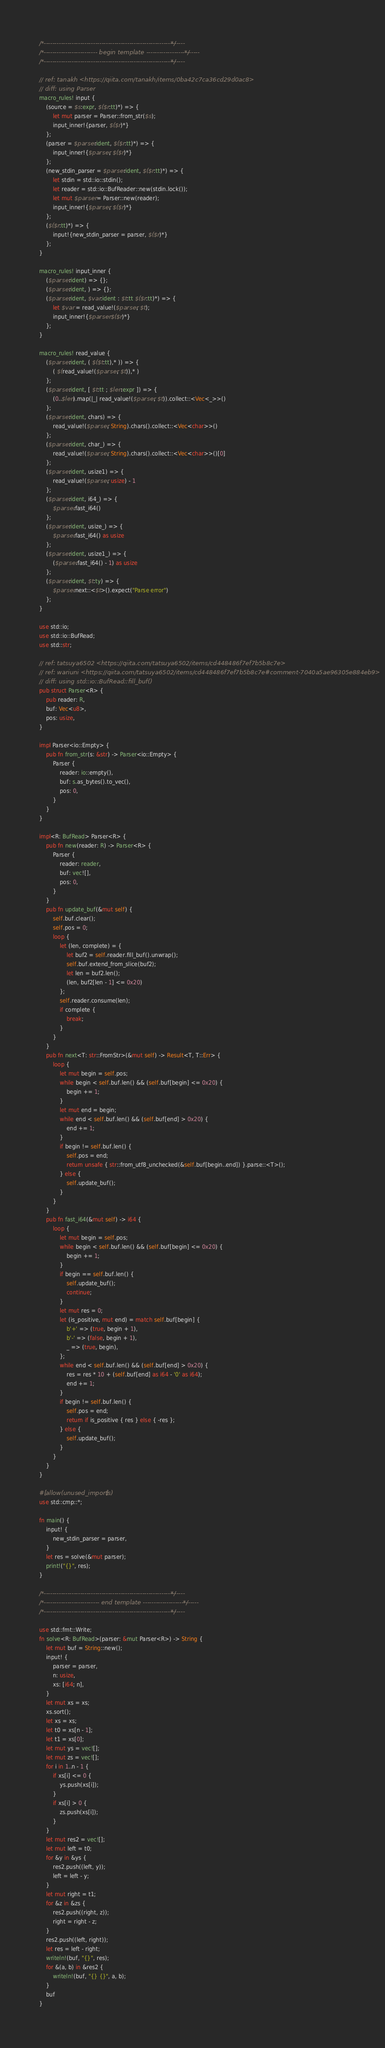Convert code to text. <code><loc_0><loc_0><loc_500><loc_500><_Rust_>/*------------------------------------------------------------------*/
/*------------------------- begin template -------------------------*/
/*------------------------------------------------------------------*/

// ref: tanakh <https://qiita.com/tanakh/items/0ba42c7ca36cd29d0ac8>
// diff: using Parser
macro_rules! input {
    (source = $s:expr, $($r:tt)*) => {
        let mut parser = Parser::from_str($s);
        input_inner!{parser, $($r)*}
    };
    (parser = $parser:ident, $($r:tt)*) => {
        input_inner!{$parser, $($r)*}
    };
    (new_stdin_parser = $parser:ident, $($r:tt)*) => {
        let stdin = std::io::stdin();
        let reader = std::io::BufReader::new(stdin.lock());
        let mut $parser = Parser::new(reader);
        input_inner!{$parser, $($r)*}
    };
    ($($r:tt)*) => {
        input!{new_stdin_parser = parser, $($r)*}
    };
}

macro_rules! input_inner {
    ($parser:ident) => {};
    ($parser:ident, ) => {};
    ($parser:ident, $var:ident : $t:tt $($r:tt)*) => {
        let $var = read_value!($parser, $t);
        input_inner!{$parser $($r)*}
    };
}

macro_rules! read_value {
    ($parser:ident, ( $($t:tt),* )) => {
        ( $(read_value!($parser, $t)),* )
    };
    ($parser:ident, [ $t:tt ; $len:expr ]) => {
        (0..$len).map(|_| read_value!($parser, $t)).collect::<Vec<_>>()
    };
    ($parser:ident, chars) => {
        read_value!($parser, String).chars().collect::<Vec<char>>()
    };
    ($parser:ident, char_) => {
        read_value!($parser, String).chars().collect::<Vec<char>>()[0]
    };
    ($parser:ident, usize1) => {
        read_value!($parser, usize) - 1
    };
    ($parser:ident, i64_) => {
        $parser.fast_i64()
    };
    ($parser:ident, usize_) => {
        $parser.fast_i64() as usize
    };
    ($parser:ident, usize1_) => {
        ($parser.fast_i64() - 1) as usize
    };
    ($parser:ident, $t:ty) => {
        $parser.next::<$t>().expect("Parse error")
    };
}

use std::io;
use std::io::BufRead;
use std::str;

// ref: tatsuya6502 <https://qiita.com/tatsuya6502/items/cd448486f7ef7b5b8c7e>
// ref: wariuni <https://qiita.com/tatsuya6502/items/cd448486f7ef7b5b8c7e#comment-7040a5ae96305e884eb9>
// diff: using std::io::BufRead::fill_buf()
pub struct Parser<R> {
    pub reader: R,
    buf: Vec<u8>,
    pos: usize,
}

impl Parser<io::Empty> {
    pub fn from_str(s: &str) -> Parser<io::Empty> {
        Parser {
            reader: io::empty(),
            buf: s.as_bytes().to_vec(),
            pos: 0,
        }
    }
}

impl<R: BufRead> Parser<R> {
    pub fn new(reader: R) -> Parser<R> {
        Parser {
            reader: reader,
            buf: vec![],
            pos: 0,
        }
    }
    pub fn update_buf(&mut self) {
        self.buf.clear();
        self.pos = 0;
        loop {
            let (len, complete) = {
                let buf2 = self.reader.fill_buf().unwrap();
                self.buf.extend_from_slice(buf2);
                let len = buf2.len();
                (len, buf2[len - 1] <= 0x20)
            };
            self.reader.consume(len);
            if complete {
                break;
            }
        }
    }
    pub fn next<T: str::FromStr>(&mut self) -> Result<T, T::Err> {
        loop {
            let mut begin = self.pos;
            while begin < self.buf.len() && (self.buf[begin] <= 0x20) {
                begin += 1;
            }
            let mut end = begin;
            while end < self.buf.len() && (self.buf[end] > 0x20) {
                end += 1;
            }
            if begin != self.buf.len() {
                self.pos = end;
                return unsafe { str::from_utf8_unchecked(&self.buf[begin..end]) }.parse::<T>();
            } else {
                self.update_buf();
            }
        }
    }
    pub fn fast_i64(&mut self) -> i64 {
        loop {
            let mut begin = self.pos;
            while begin < self.buf.len() && (self.buf[begin] <= 0x20) {
                begin += 1;
            }
            if begin == self.buf.len() {
                self.update_buf();
                continue;
            }
            let mut res = 0;
            let (is_positive, mut end) = match self.buf[begin] {
                b'+' => (true, begin + 1),
                b'-' => (false, begin + 1),
                _ => (true, begin),
            };
            while end < self.buf.len() && (self.buf[end] > 0x20) {
                res = res * 10 + (self.buf[end] as i64 - '0' as i64);
                end += 1;
            }
            if begin != self.buf.len() {
                self.pos = end;
                return if is_positive { res } else { -res };
            } else {
                self.update_buf();
            }
        }
    }
}

#[allow(unused_imports)]
use std::cmp::*;

fn main() {
    input! {
        new_stdin_parser = parser,
    }
    let res = solve(&mut parser);
    print!("{}", res);
}

/*------------------------------------------------------------------*/
/*-------------------------- end template --------------------------*/
/*------------------------------------------------------------------*/

use std::fmt::Write;
fn solve<R: BufRead>(parser: &mut Parser<R>) -> String {
    let mut buf = String::new();
    input! {
        parser = parser,
        n: usize,
        xs: [i64; n],
    }
    let mut xs = xs;
    xs.sort();
    let xs = xs;
    let t0 = xs[n - 1];
    let t1 = xs[0];
    let mut ys = vec![];
    let mut zs = vec![];
    for i in 1..n - 1 {
        if xs[i] <= 0 {
            ys.push(xs[i]);
        }
        if xs[i] > 0 {
            zs.push(xs[i]);
        }
    }
    let mut res2 = vec![];
    let mut left = t0;
    for &y in &ys {
        res2.push((left, y));
        left = left - y;
    }
    let mut right = t1;
    for &z in &zs {
        res2.push((right, z));
        right = right - z;
    }
    res2.push((left, right));
    let res = left - right;
    writeln!(buf, "{}", res);
    for &(a, b) in &res2 {
        writeln!(buf, "{} {}", a, b);
    }
    buf
}
</code> 